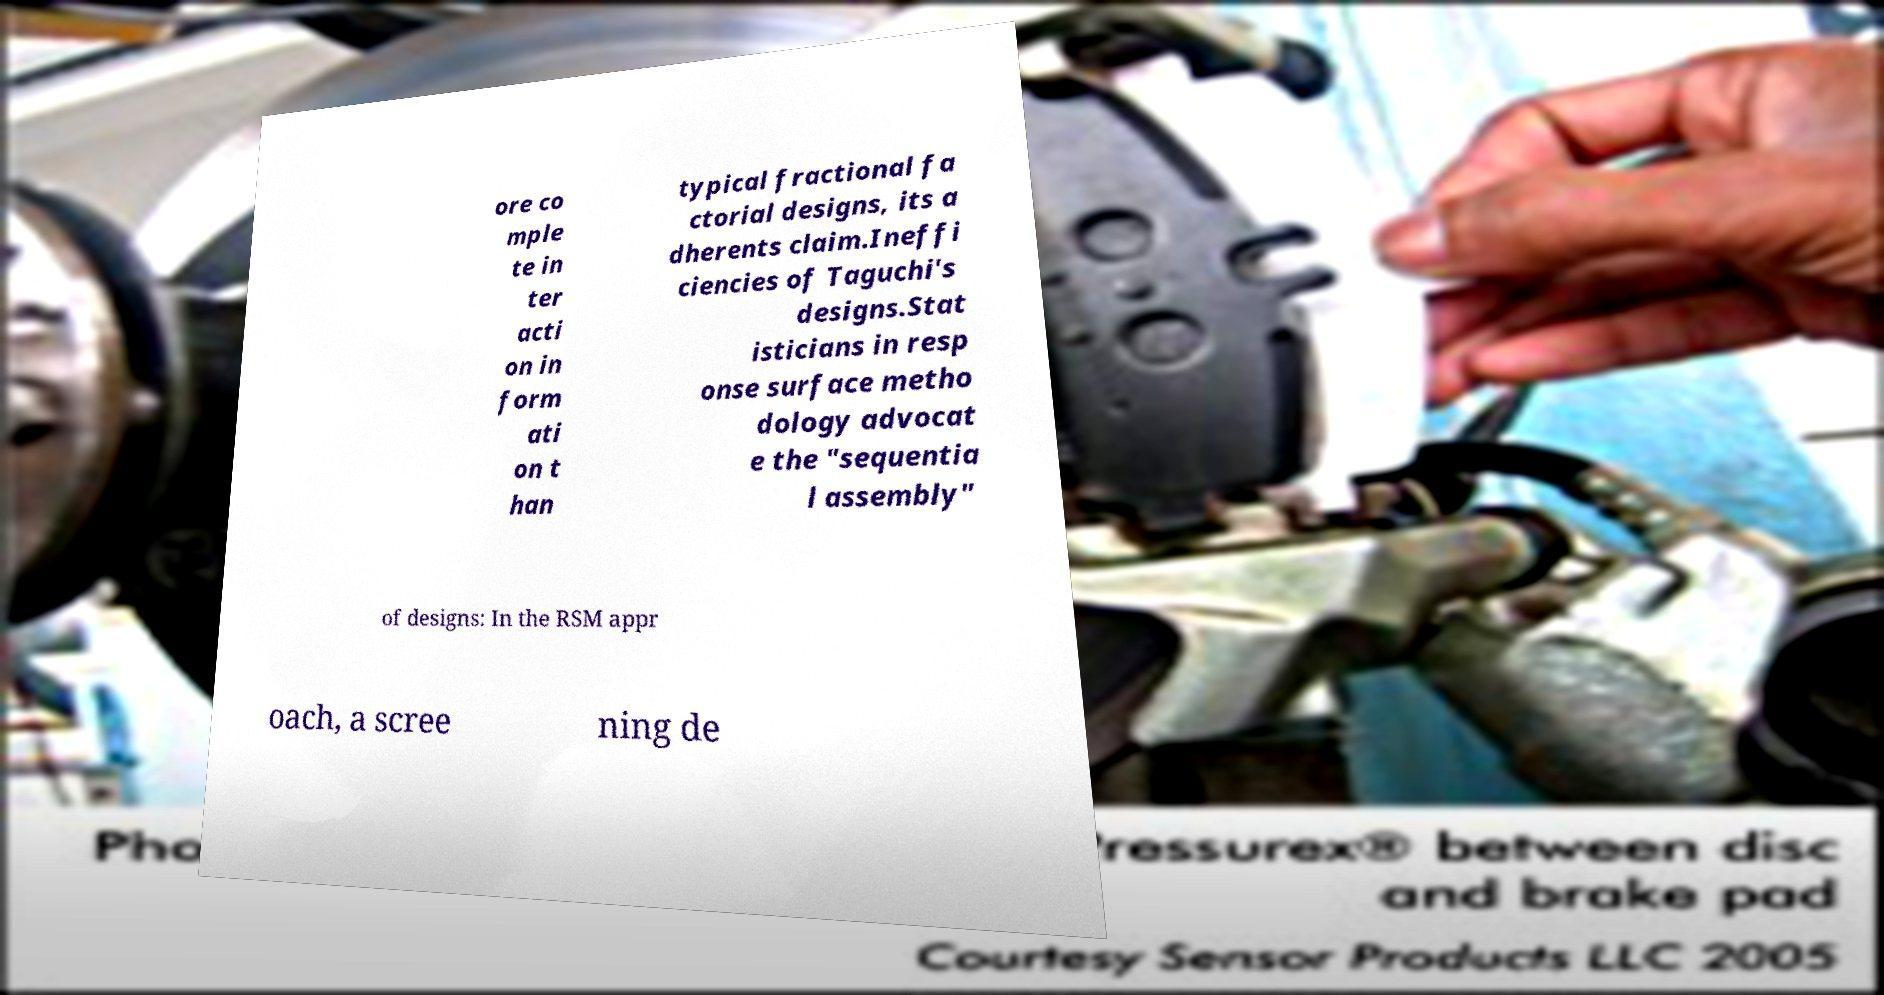Please identify and transcribe the text found in this image. ore co mple te in ter acti on in form ati on t han typical fractional fa ctorial designs, its a dherents claim.Ineffi ciencies of Taguchi's designs.Stat isticians in resp onse surface metho dology advocat e the "sequentia l assembly" of designs: In the RSM appr oach, a scree ning de 